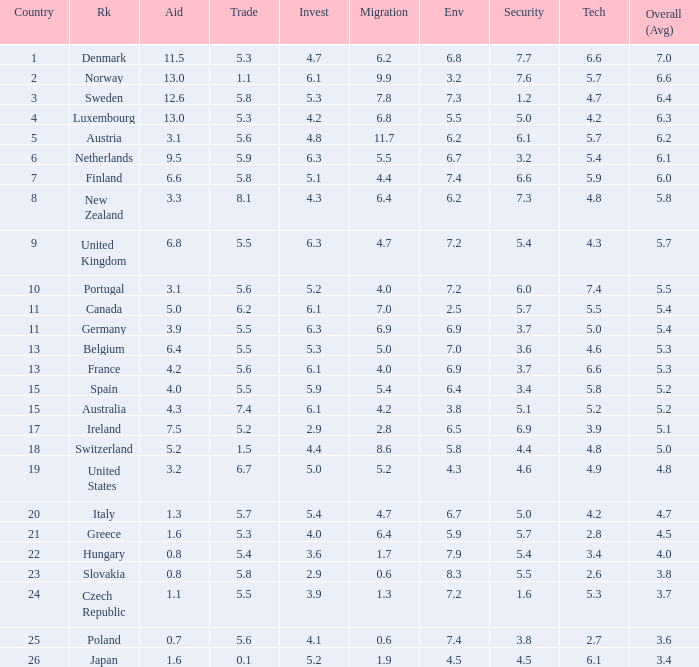What is the migration rating when trade is 5.7? 4.7. 